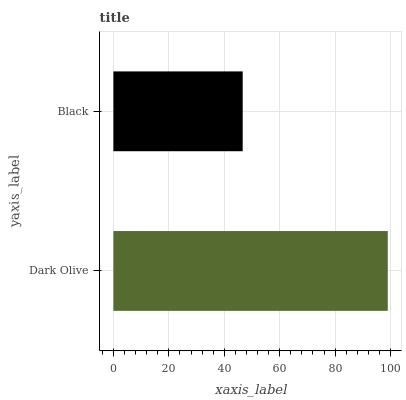Is Black the minimum?
Answer yes or no. Yes. Is Dark Olive the maximum?
Answer yes or no. Yes. Is Black the maximum?
Answer yes or no. No. Is Dark Olive greater than Black?
Answer yes or no. Yes. Is Black less than Dark Olive?
Answer yes or no. Yes. Is Black greater than Dark Olive?
Answer yes or no. No. Is Dark Olive less than Black?
Answer yes or no. No. Is Dark Olive the high median?
Answer yes or no. Yes. Is Black the low median?
Answer yes or no. Yes. Is Black the high median?
Answer yes or no. No. Is Dark Olive the low median?
Answer yes or no. No. 